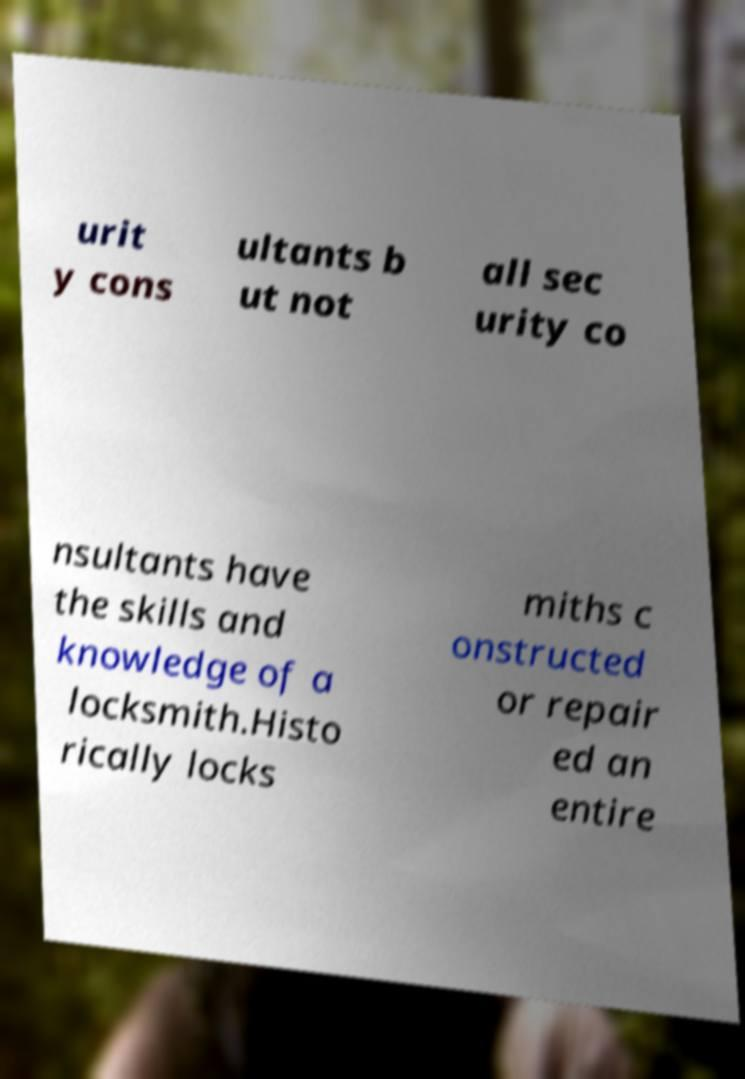Please identify and transcribe the text found in this image. urit y cons ultants b ut not all sec urity co nsultants have the skills and knowledge of a locksmith.Histo rically locks miths c onstructed or repair ed an entire 